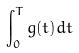Convert formula to latex. <formula><loc_0><loc_0><loc_500><loc_500>\int _ { 0 } ^ { T } g ( t ) d t</formula> 